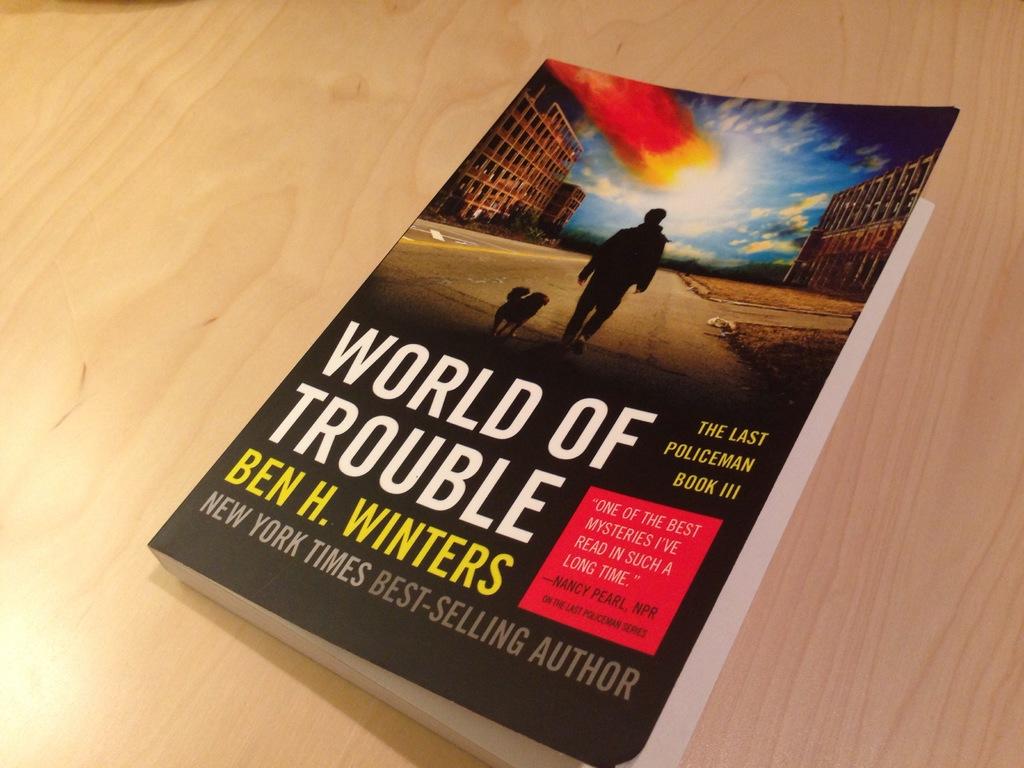Who is the author of the book?
Make the answer very short. Ben h. winters. 